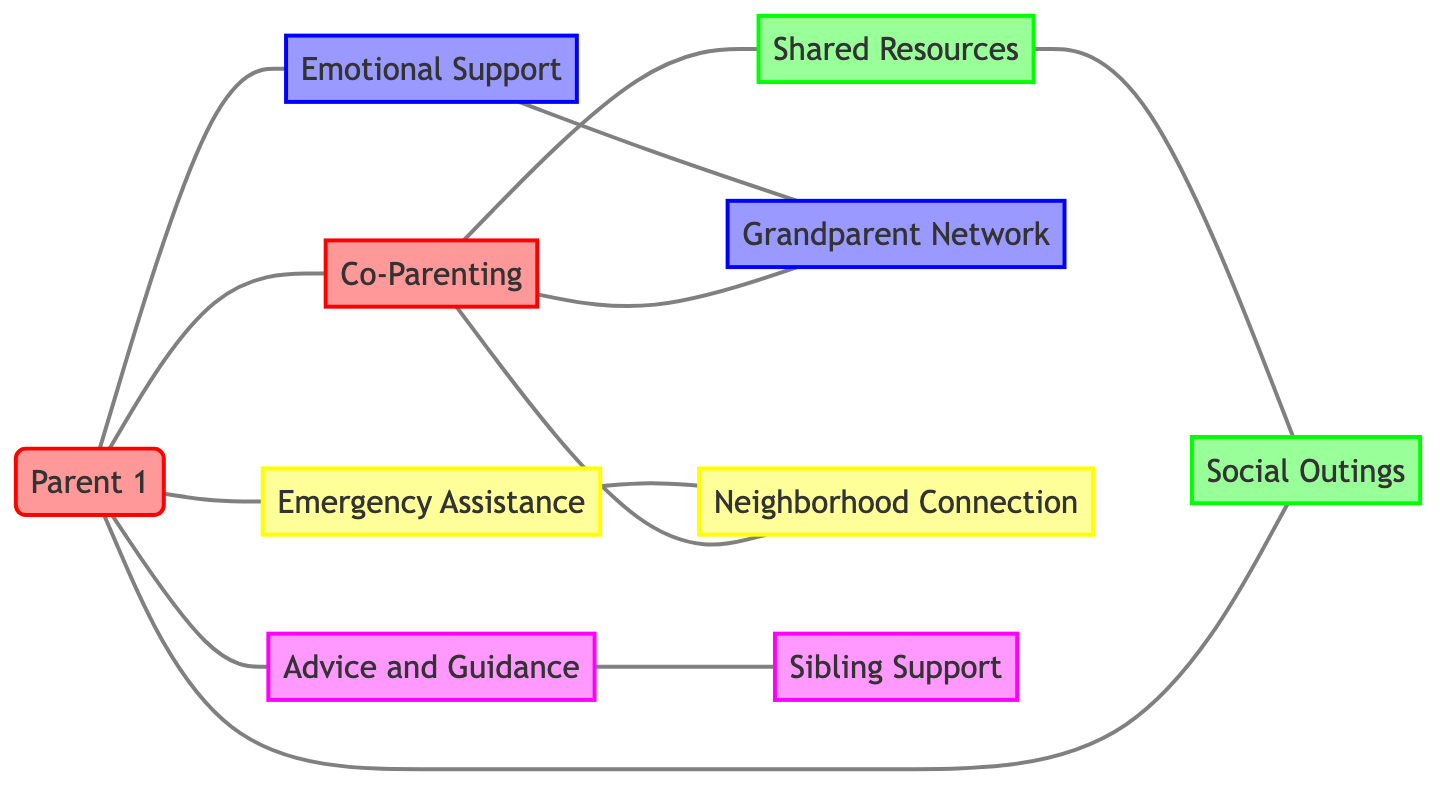What are the two types of relationships between Parent 1 and Parent 2? The diagram shows two relationships: "Co-Parenting" connects Parent 1 to Parent 2, and "Advice and Guidance" connects Parent 1 to Sibling 1 as well, but here for Parent 2 only "Financial Support" exists with Grandparent 2.
Answer: Co-Parenting, Financial Support How many neighbors are in the diagram? The diagram contains two neighbors: Neighbor 1 and Neighbor 2. Both are represented as nodes in the diagram.
Answer: 2 Which node is connected to the most other nodes? Parent 1 is connected to four other nodes: Parent 2, Friend 1, Grandparent 1, and Neighbor 1, which indicates it is the most connected node in the diagram.
Answer: Parent 1 What type of support does Friend 2 provide to Parent 2? The relationship labeled "Shared Resources" connects Friend 2 and Parent 2, which indicates that this is the type of support provided.
Answer: Shared Resources How many total edges are there in the diagram? By counting the connections, there are eleven edges that represent various support systems among the nodes in the diagram.
Answer: 11 Is there a direct connection between Grandparent 1 and Parent 2? Upon examining the diagram, Grandparent 1 has no edge connecting it directly to Parent 2, indicating that there is no relationship depicted between these two nodes.
Answer: No What is the relationship type between Sibling 1 and Sibling 2? The edge labeled "Sibling Support" connects Sibling 1 and Sibling 2, explicitly defining the relationship type between these two nodes.
Answer: Sibling Support Which grandparents are connected to each other in the diagram? The relationship "Grandparent Network" illustrates the connection between Grandparent 1 and Grandparent 2 in the diagram, confirming their relationship.
Answer: Grandparent 1, Grandparent 2 